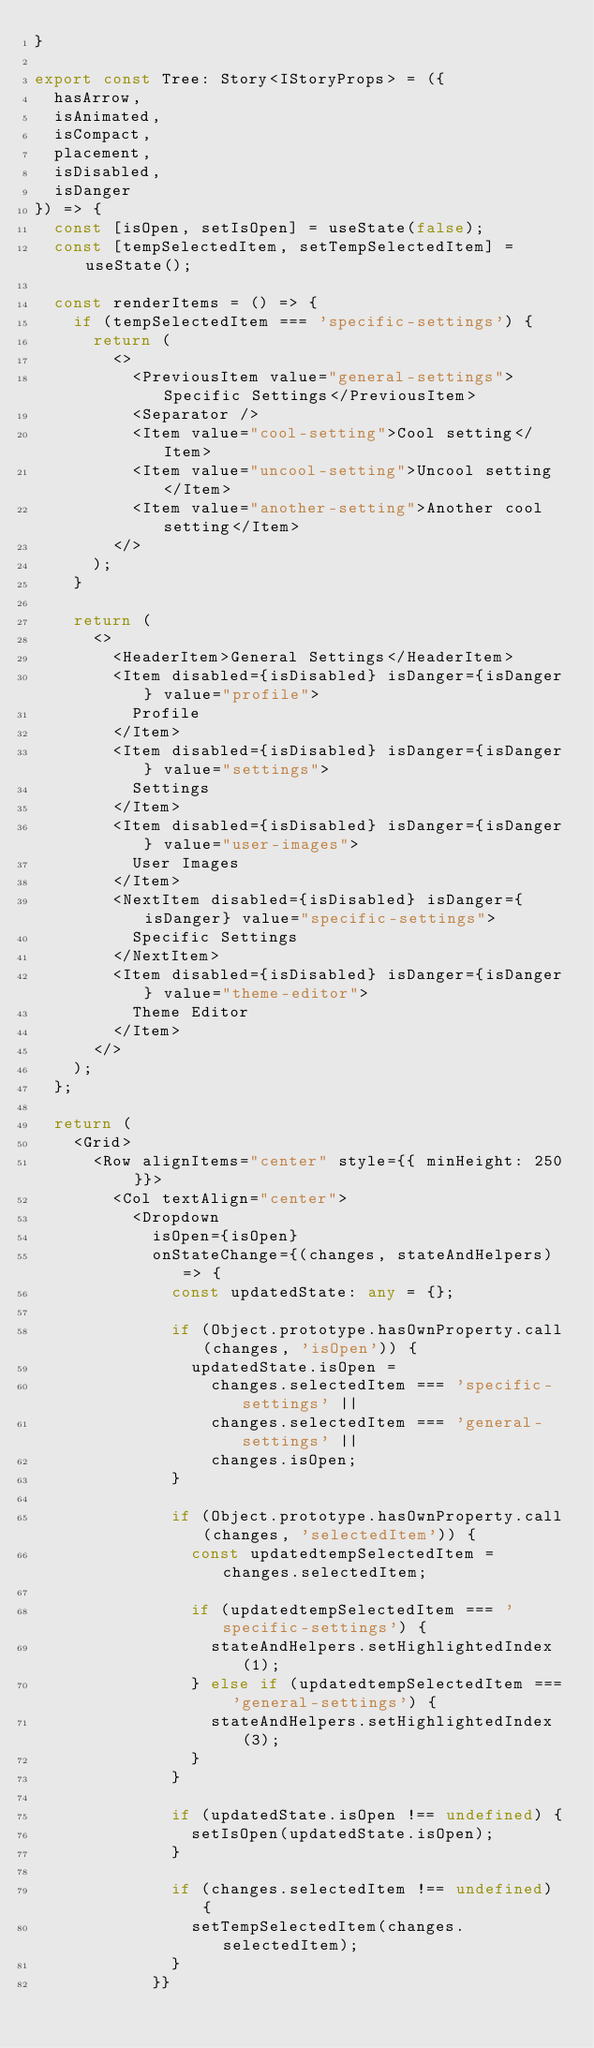<code> <loc_0><loc_0><loc_500><loc_500><_TypeScript_>}

export const Tree: Story<IStoryProps> = ({
  hasArrow,
  isAnimated,
  isCompact,
  placement,
  isDisabled,
  isDanger
}) => {
  const [isOpen, setIsOpen] = useState(false);
  const [tempSelectedItem, setTempSelectedItem] = useState();

  const renderItems = () => {
    if (tempSelectedItem === 'specific-settings') {
      return (
        <>
          <PreviousItem value="general-settings">Specific Settings</PreviousItem>
          <Separator />
          <Item value="cool-setting">Cool setting</Item>
          <Item value="uncool-setting">Uncool setting</Item>
          <Item value="another-setting">Another cool setting</Item>
        </>
      );
    }

    return (
      <>
        <HeaderItem>General Settings</HeaderItem>
        <Item disabled={isDisabled} isDanger={isDanger} value="profile">
          Profile
        </Item>
        <Item disabled={isDisabled} isDanger={isDanger} value="settings">
          Settings
        </Item>
        <Item disabled={isDisabled} isDanger={isDanger} value="user-images">
          User Images
        </Item>
        <NextItem disabled={isDisabled} isDanger={isDanger} value="specific-settings">
          Specific Settings
        </NextItem>
        <Item disabled={isDisabled} isDanger={isDanger} value="theme-editor">
          Theme Editor
        </Item>
      </>
    );
  };

  return (
    <Grid>
      <Row alignItems="center" style={{ minHeight: 250 }}>
        <Col textAlign="center">
          <Dropdown
            isOpen={isOpen}
            onStateChange={(changes, stateAndHelpers) => {
              const updatedState: any = {};

              if (Object.prototype.hasOwnProperty.call(changes, 'isOpen')) {
                updatedState.isOpen =
                  changes.selectedItem === 'specific-settings' ||
                  changes.selectedItem === 'general-settings' ||
                  changes.isOpen;
              }

              if (Object.prototype.hasOwnProperty.call(changes, 'selectedItem')) {
                const updatedtempSelectedItem = changes.selectedItem;

                if (updatedtempSelectedItem === 'specific-settings') {
                  stateAndHelpers.setHighlightedIndex(1);
                } else if (updatedtempSelectedItem === 'general-settings') {
                  stateAndHelpers.setHighlightedIndex(3);
                }
              }

              if (updatedState.isOpen !== undefined) {
                setIsOpen(updatedState.isOpen);
              }

              if (changes.selectedItem !== undefined) {
                setTempSelectedItem(changes.selectedItem);
              }
            }}</code> 